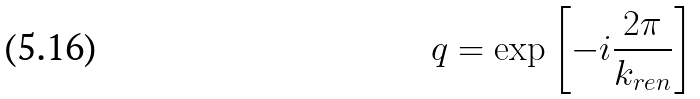<formula> <loc_0><loc_0><loc_500><loc_500>q = \exp \left [ - i \frac { 2 \pi } { k _ { r e n } } \right ]</formula> 